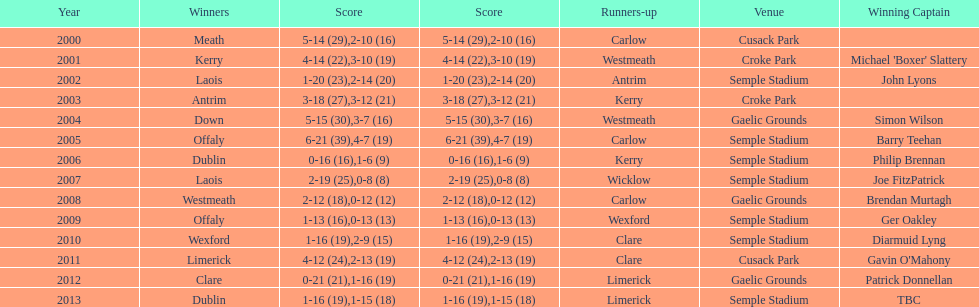Who claimed victory after 2007? Laois. 